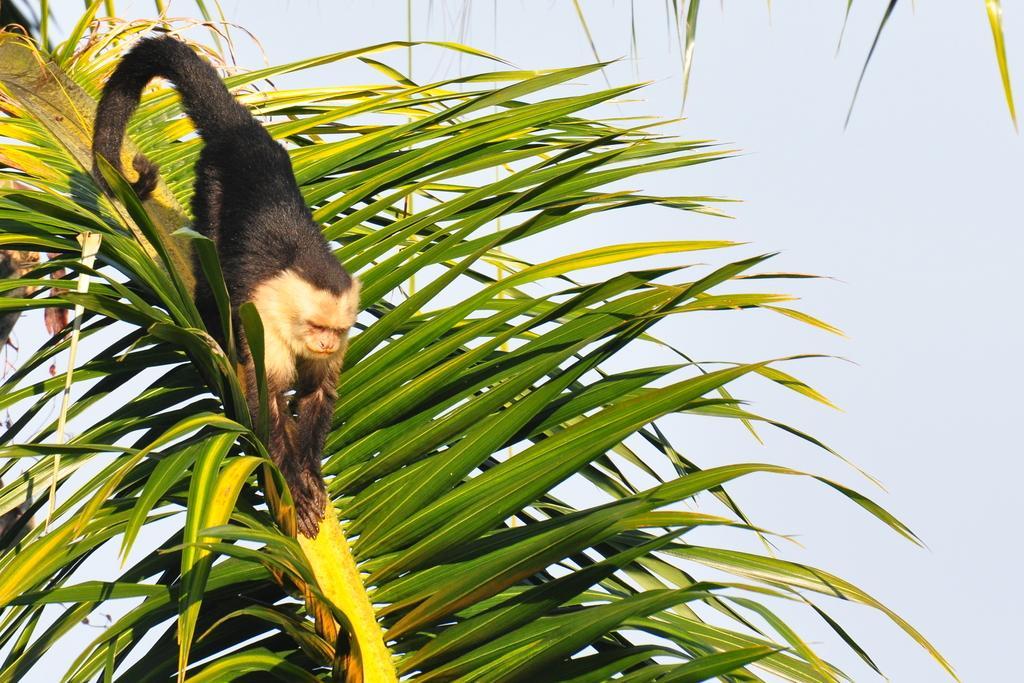Could you give a brief overview of what you see in this image? In this image there is a tree truncated towards the bottom of the image, there is an animal on the tree, there are leaves truncated towards the top of the image, at the background of the image there is the sky. 